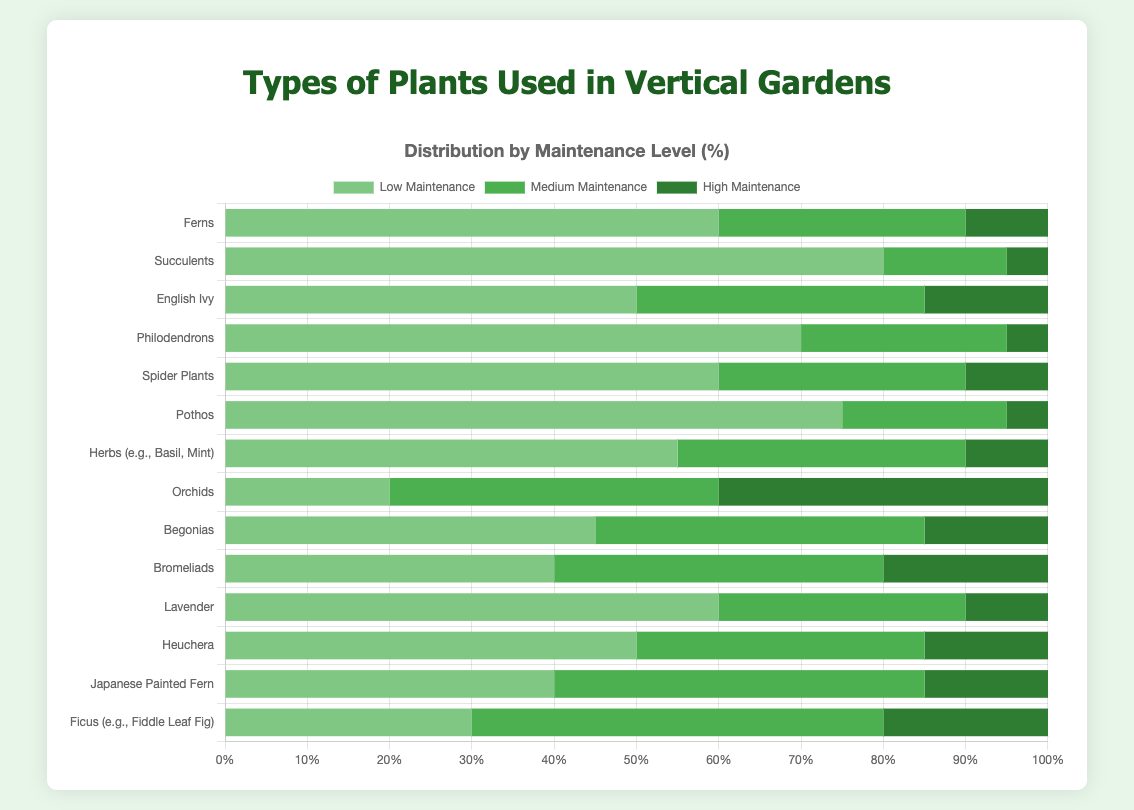Which plant has the highest percentage of low maintenance? Succulents have the highest low maintenance percentage of 80%, which is evident as the longest green section in the bar for Succulents.
Answer: Succulents Which plant requires the highest amount of high maintenance? Orchids have the highest high maintenance percentage of 40%, identified by the longest dark green section in the bar for Orchids.
Answer: Orchids Compare the low maintenance percentages of Ferns and Pothos. Ferns have 60% low maintenance, while Pothos have 75%. By comparing the lengths of the green sections, Pothos has a higher percentage than Ferns.
Answer: Pothos has a higher percentage What is the total percentage of medium maintenance for English Ivy and Japanese Painted Fern? English Ivy has 35% and Japanese Painted Fern has 45% medium maintenance. Adding them together gives 35% + 45% = 80%.
Answer: 80% Among the plants, which one has an equal distribution of low, medium, and high maintenance? None of the plants have an equal distribution.
Answer: None What is the difference in high maintenance percentages between Bromeliads and Ficus? Bromeliads have 20% high maintenance, while Ficus has 20%. The difference is 20% - 20% = 0%.
Answer: 0% Which plant with more than 60% low maintenance also has more than 30% medium maintenance? Philodendrons have 70% low maintenance and 25% medium maintenance, which meets the low maintenance criterion but fails in the medium maintenance criterion since 25% < 30%. Pothos has 75% low maintenance and 20% medium maintenance, which also fails in the medium criterion. Hence, none of the plants satisfy the condition.
Answer: None What is the average high maintenance percentage for all plants? Sum of high maintenance percentages is 10 + 5 + 15 + 5 + 10 + 5 + 10 + 40 + 15 + 20 + 10 + 15 + 15 + 20 = 195. There are 14 plants, so the average = 195/14 ≈ 13.93%.
Answer: 13.93% Which plant has the largest difference between low and high maintenance percentage? Succulents have 80% low maintenance and 5% high maintenance. The difference is 80% - 5% = 75%. Other plants have smaller differences.
Answer: Succulents Which plants have exactly 40% medium maintenance? Orchids, Begonias, Bromeliads, and Japanese Painted Fern all have a 40% medium maintenance, identified by checking the labels next to bars with the middle section painted dark green covering 40%.
Answer: Orchids, Begonias, Bromeliads, Japanese Painted Fern 